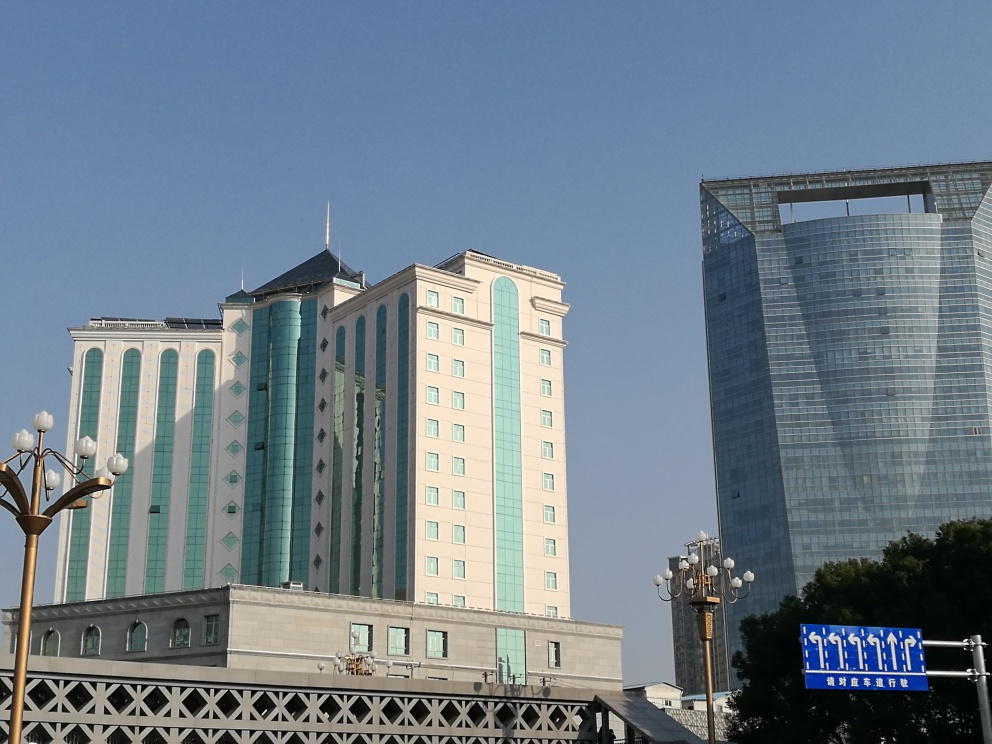Can you describe the atmosphere of the location shown in the picture? The atmosphere appears to be calm and orderly, possibly in a business district based on the presence of the large buildings. The blue sky suggests a pleasant day, and the lack of visible pedestrians implies it might be a less-traveled area or taken at a time of low pedestrian activity. The contrast between the buildings implies a sense of growth or transformation in the area. 